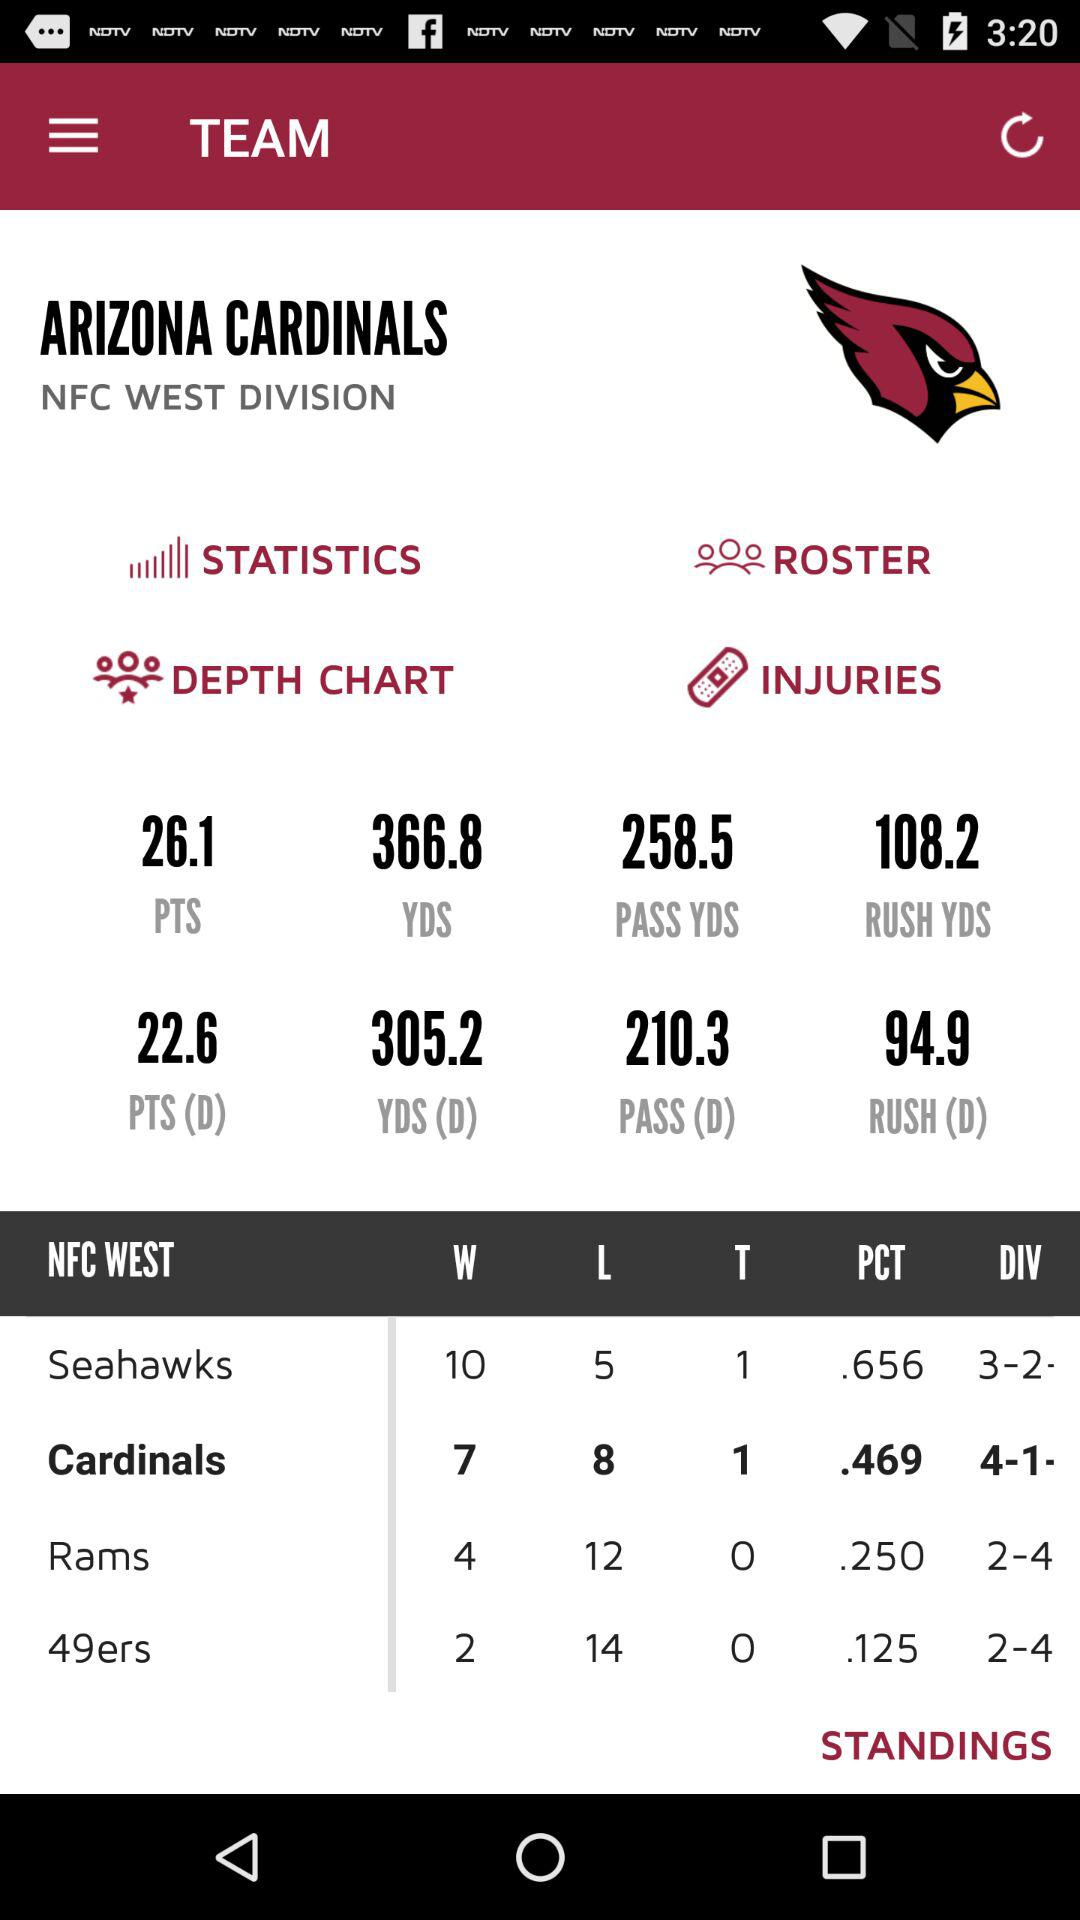Which team has a better record, the Cardinals or the Rams?
Answer the question using a single word or phrase. Cardinals 